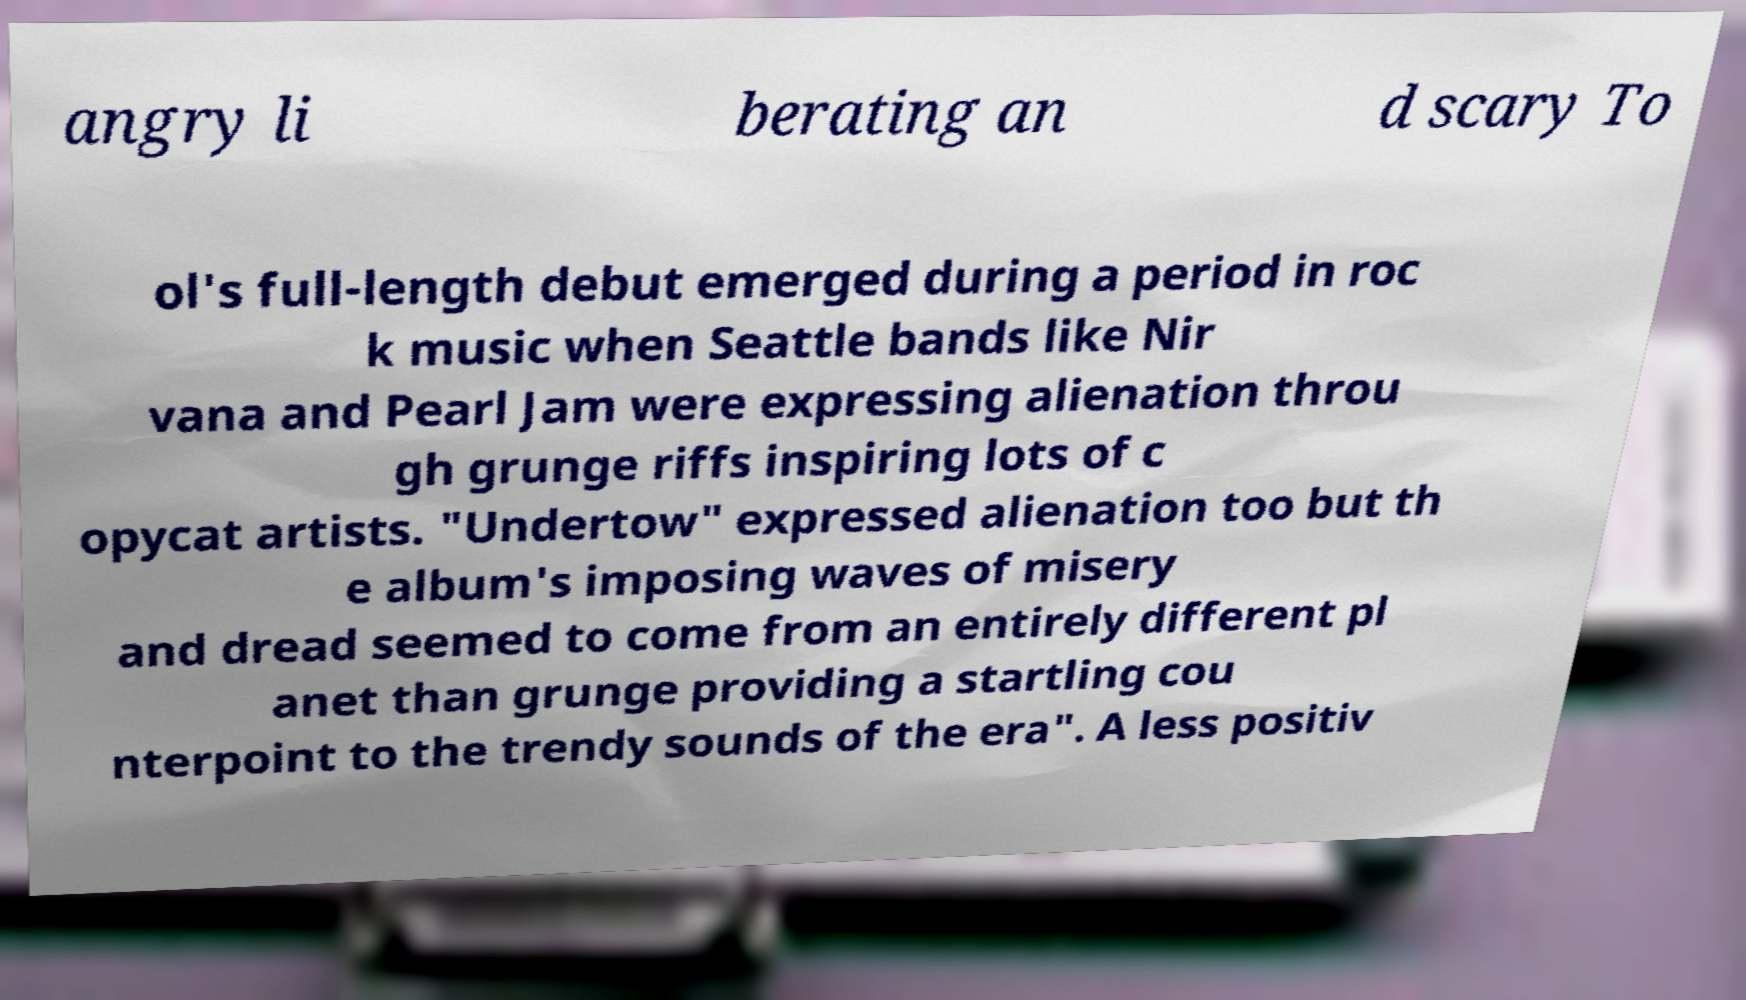Please read and relay the text visible in this image. What does it say? angry li berating an d scary To ol's full-length debut emerged during a period in roc k music when Seattle bands like Nir vana and Pearl Jam were expressing alienation throu gh grunge riffs inspiring lots of c opycat artists. "Undertow" expressed alienation too but th e album's imposing waves of misery and dread seemed to come from an entirely different pl anet than grunge providing a startling cou nterpoint to the trendy sounds of the era". A less positiv 